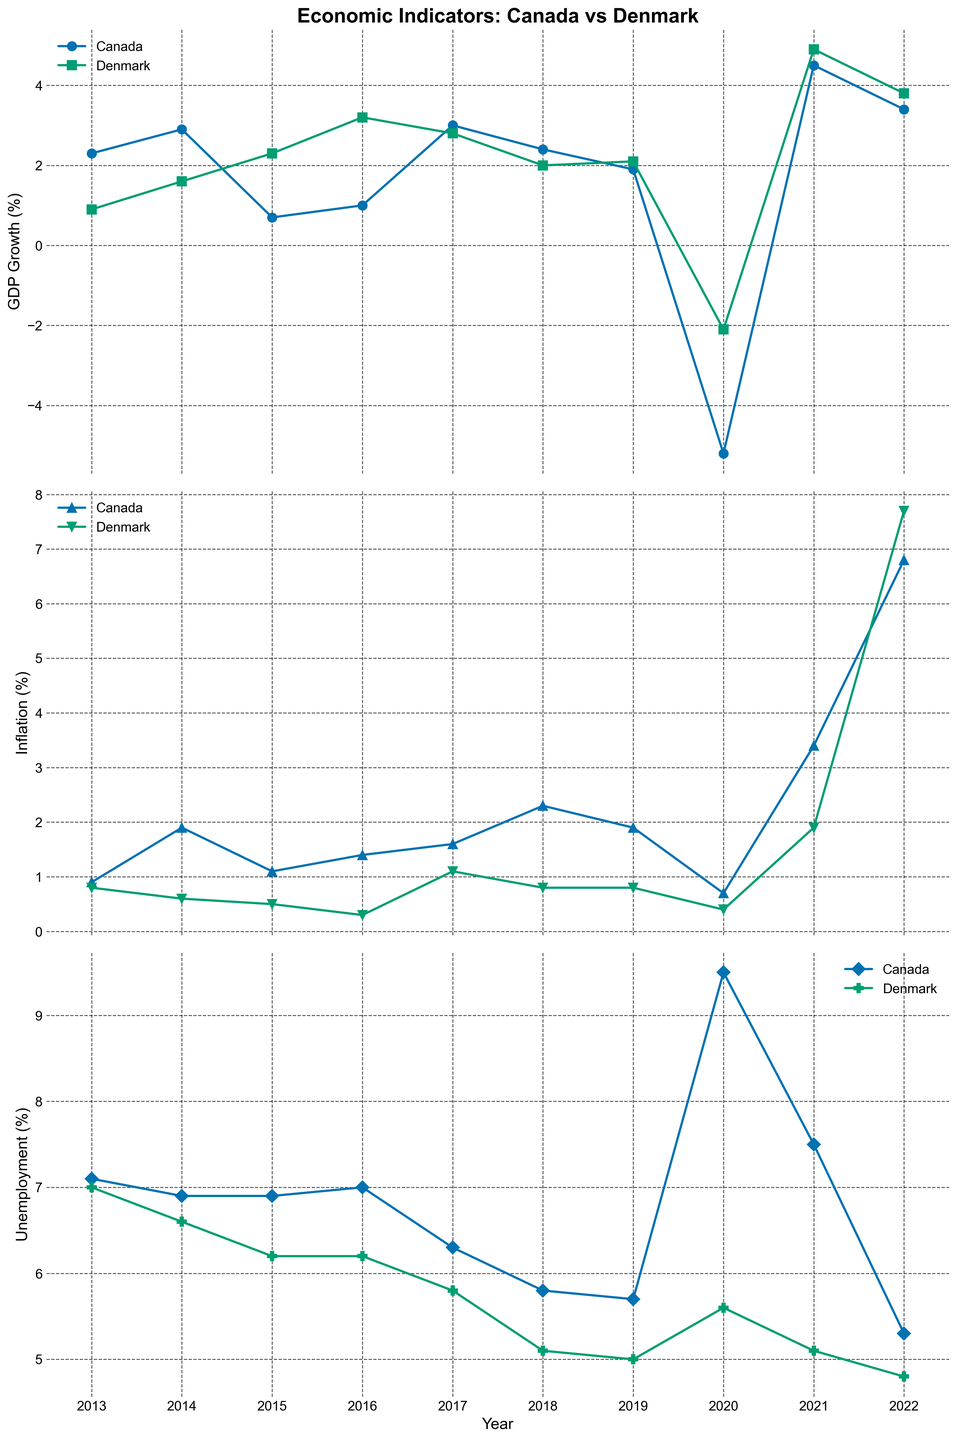What was the GDP growth rate in Canada in 2021? First, locate the GDP growth subplot and then find the year 2021 on the x-axis. Trace upward to find the data point for Canada and note the corresponding value, which is 4.5%.
Answer: 4.5% How did the unemployment rate change in Denmark from 2013 to 2022? Locate the unemployment subplot and observe the data points for Denmark at the years 2013 and 2022. In 2013, the unemployment rate was 7.0%, and in 2022, it was 4.8%. Calculate the difference by subtracting 4.8% from 7.0%, which gives a change of -2.2%.
Answer: -2.2% Between 2013 and 2022, which country had the higher average inflation rate? Locate the inflation subplot and gather the inflation rates for both countries from 2013 to 2022. Calculate the average for both countries: for Canada (0.9+1.9+1.1+1.4+1.6+2.3+1.9+0.7+3.4+6.8)/10 = 2.0% and for Denmark (0.8+0.6+0.5+0.3+1.1+0.8+0.8+0.4+1.9+7.7)/10 = 1.49%. Canada's average inflation rate is higher.
Answer: Canada What is the difference in GDP growth rate between Canada and Denmark in 2020? Locate the GDP growth subplot and find the GDP growth rates for both Canada and Denmark in 2020. Canada's GDP growth rate was -5.2% and Denmark's was -2.1%. Calculate the difference: -5.2 - (-2.1) = -3.1%.
Answer: -3.1% Which year did Canada record its highest unemployment rate? Locate the unemployment subplot and find the highest data point for Canada. The highest unemployment rate occurred in 2020 with a value of 9.5%.
Answer: 2020 During which year did Denmark experience the highest inflation rate, and what was it? Locate the inflation subplot and identify the highest data point for Denmark. The highest inflation rate was in 2022 with a value of 7.7%.
Answer: 2022 How did Canada's inflation rate in 2022 compare to Denmark's? Locate the inflation subplot and find the inflation rates for both countries in 2022. Canada's inflation rate in 2022 was 6.8%, and Denmark's was 7.7%. Canada's rate was lower.
Answer: Lower What is the trend in Denmark's GDP growth rate from 2013 to 2022? Locate the GDP growth subplot and trace Denmark's GDP growth line from 2013 to 2022. The trend shows an initial increase from 0.9% in 2013 to a peak of 4.9% in 2021, followed by a slight decrease to 3.8% in 2022.
Answer: Increasing with fluctuations In which years did Canada's unemployment rate decrease compared to the previous year? Locate the unemployment subplot and observe the trend line for Canada. Identify the years where the unemployment rate decreased compared to the previous year: 2014 (6.9% from 7.1% in 2013), 2017 (6.3% from 7.0% in 2016), 2018 (5.8% from 6.3% in 2017), 2019 (5.7% from 5.8% in 2018), 2022 (5.3% from 7.5% in 2021).
Answer: 2014, 2017, 2018, 2019, 2022 